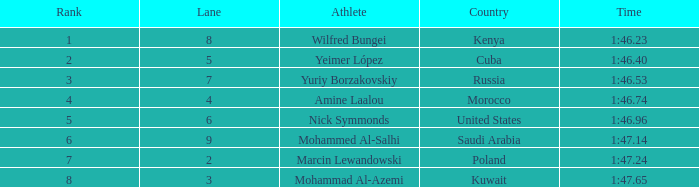For an athlete with a 1:47.65 time and in lane 3 or greater, what is their standing? None. 